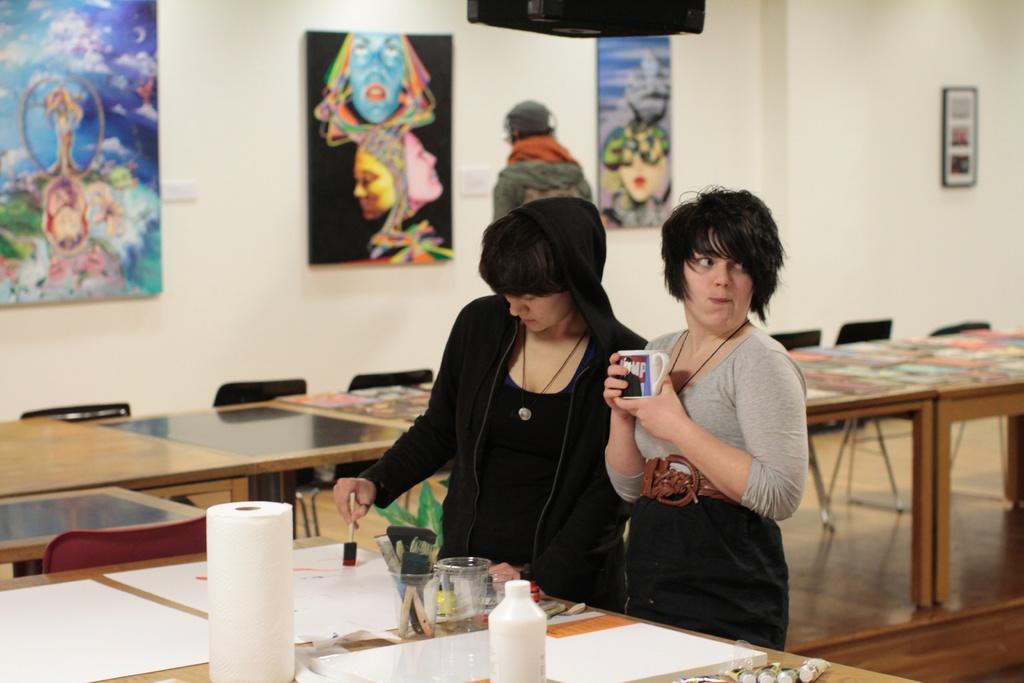Describe this image in one or two sentences. In this image there are three persons, one is standing and holding a cup and other person is standing and painting. There are sheets, tissues, glass, brushes, bottle on the table, at the back there are paintings on the wall. 